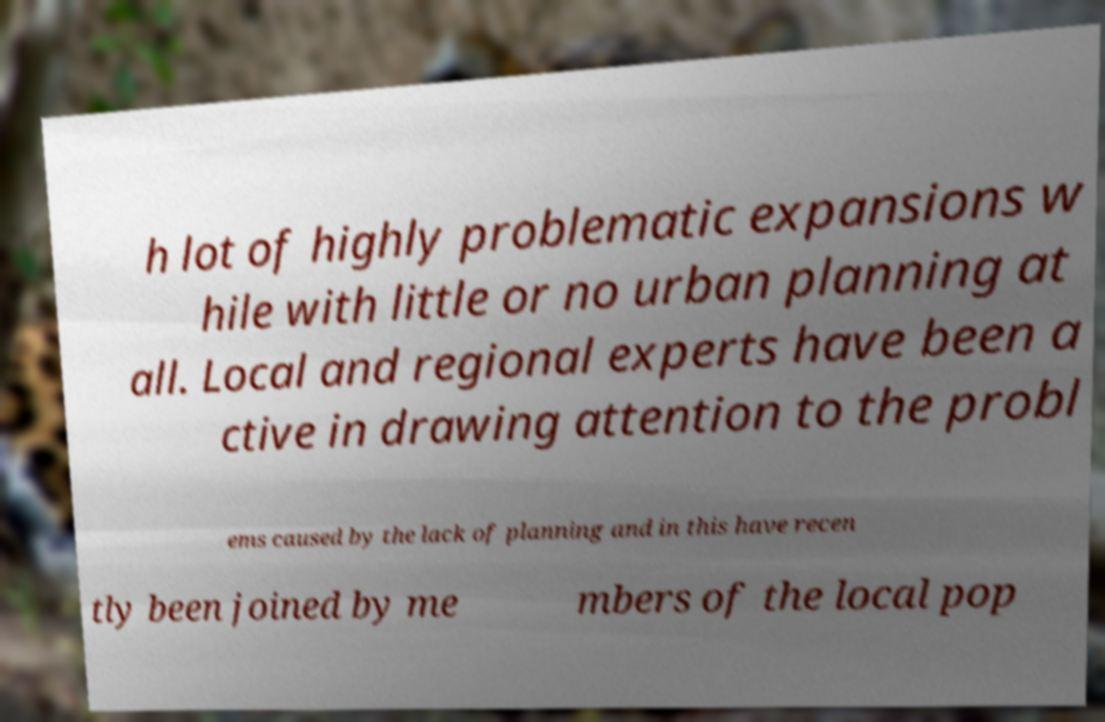Please identify and transcribe the text found in this image. h lot of highly problematic expansions w hile with little or no urban planning at all. Local and regional experts have been a ctive in drawing attention to the probl ems caused by the lack of planning and in this have recen tly been joined by me mbers of the local pop 